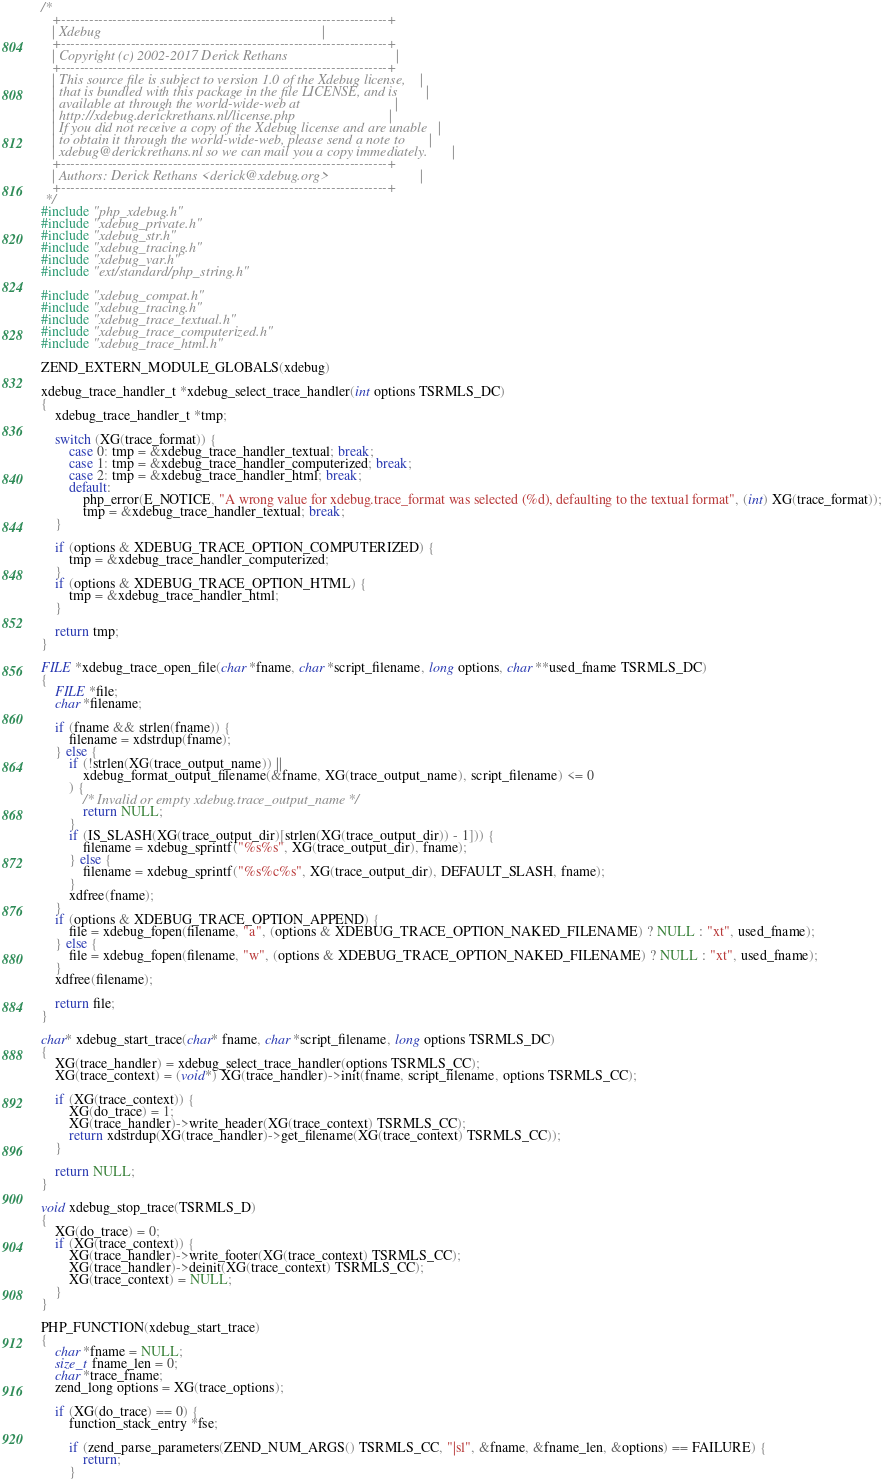<code> <loc_0><loc_0><loc_500><loc_500><_C_>/*
   +----------------------------------------------------------------------+
   | Xdebug                                                               |
   +----------------------------------------------------------------------+
   | Copyright (c) 2002-2017 Derick Rethans                               |
   +----------------------------------------------------------------------+
   | This source file is subject to version 1.0 of the Xdebug license,    |
   | that is bundled with this package in the file LICENSE, and is        |
   | available at through the world-wide-web at                           |
   | http://xdebug.derickrethans.nl/license.php                           |
   | If you did not receive a copy of the Xdebug license and are unable   |
   | to obtain it through the world-wide-web, please send a note to       |
   | xdebug@derickrethans.nl so we can mail you a copy immediately.       |
   +----------------------------------------------------------------------+
   | Authors: Derick Rethans <derick@xdebug.org>                          |
   +----------------------------------------------------------------------+
 */
#include "php_xdebug.h"
#include "xdebug_private.h"
#include "xdebug_str.h"
#include "xdebug_tracing.h"
#include "xdebug_var.h"
#include "ext/standard/php_string.h"

#include "xdebug_compat.h"
#include "xdebug_tracing.h"
#include "xdebug_trace_textual.h"
#include "xdebug_trace_computerized.h"
#include "xdebug_trace_html.h"

ZEND_EXTERN_MODULE_GLOBALS(xdebug)

xdebug_trace_handler_t *xdebug_select_trace_handler(int options TSRMLS_DC)
{
	xdebug_trace_handler_t *tmp;

	switch (XG(trace_format)) {
		case 0: tmp = &xdebug_trace_handler_textual; break;
		case 1: tmp = &xdebug_trace_handler_computerized; break;
		case 2: tmp = &xdebug_trace_handler_html; break;
		default:
			php_error(E_NOTICE, "A wrong value for xdebug.trace_format was selected (%d), defaulting to the textual format", (int) XG(trace_format));
			tmp = &xdebug_trace_handler_textual; break;
	}

	if (options & XDEBUG_TRACE_OPTION_COMPUTERIZED) {
		tmp = &xdebug_trace_handler_computerized;
	}
	if (options & XDEBUG_TRACE_OPTION_HTML) {
		tmp = &xdebug_trace_handler_html;
	}

	return tmp;
}

FILE *xdebug_trace_open_file(char *fname, char *script_filename, long options, char **used_fname TSRMLS_DC)
{
	FILE *file;
	char *filename;

	if (fname && strlen(fname)) {
		filename = xdstrdup(fname);
	} else {
		if (!strlen(XG(trace_output_name)) ||
			xdebug_format_output_filename(&fname, XG(trace_output_name), script_filename) <= 0
		) {
			/* Invalid or empty xdebug.trace_output_name */
			return NULL;
		}
		if (IS_SLASH(XG(trace_output_dir)[strlen(XG(trace_output_dir)) - 1])) {
			filename = xdebug_sprintf("%s%s", XG(trace_output_dir), fname);
		} else {
			filename = xdebug_sprintf("%s%c%s", XG(trace_output_dir), DEFAULT_SLASH, fname);
		}
		xdfree(fname);
	}
	if (options & XDEBUG_TRACE_OPTION_APPEND) {
		file = xdebug_fopen(filename, "a", (options & XDEBUG_TRACE_OPTION_NAKED_FILENAME) ? NULL : "xt", used_fname);
	} else {
		file = xdebug_fopen(filename, "w", (options & XDEBUG_TRACE_OPTION_NAKED_FILENAME) ? NULL : "xt", used_fname);
	}
	xdfree(filename);

	return file;
}

char* xdebug_start_trace(char* fname, char *script_filename, long options TSRMLS_DC)
{
	XG(trace_handler) = xdebug_select_trace_handler(options TSRMLS_CC);
	XG(trace_context) = (void*) XG(trace_handler)->init(fname, script_filename, options TSRMLS_CC);

	if (XG(trace_context)) {
		XG(do_trace) = 1;
		XG(trace_handler)->write_header(XG(trace_context) TSRMLS_CC);
		return xdstrdup(XG(trace_handler)->get_filename(XG(trace_context) TSRMLS_CC));
	}

	return NULL;
}

void xdebug_stop_trace(TSRMLS_D)
{
	XG(do_trace) = 0;
	if (XG(trace_context)) {
		XG(trace_handler)->write_footer(XG(trace_context) TSRMLS_CC);
		XG(trace_handler)->deinit(XG(trace_context) TSRMLS_CC);
		XG(trace_context) = NULL;
	}
}

PHP_FUNCTION(xdebug_start_trace)
{
	char *fname = NULL;
	size_t fname_len = 0;
	char *trace_fname;
	zend_long options = XG(trace_options);

	if (XG(do_trace) == 0) {
		function_stack_entry *fse;

		if (zend_parse_parameters(ZEND_NUM_ARGS() TSRMLS_CC, "|sl", &fname, &fname_len, &options) == FAILURE) {
			return;
		}
</code> 